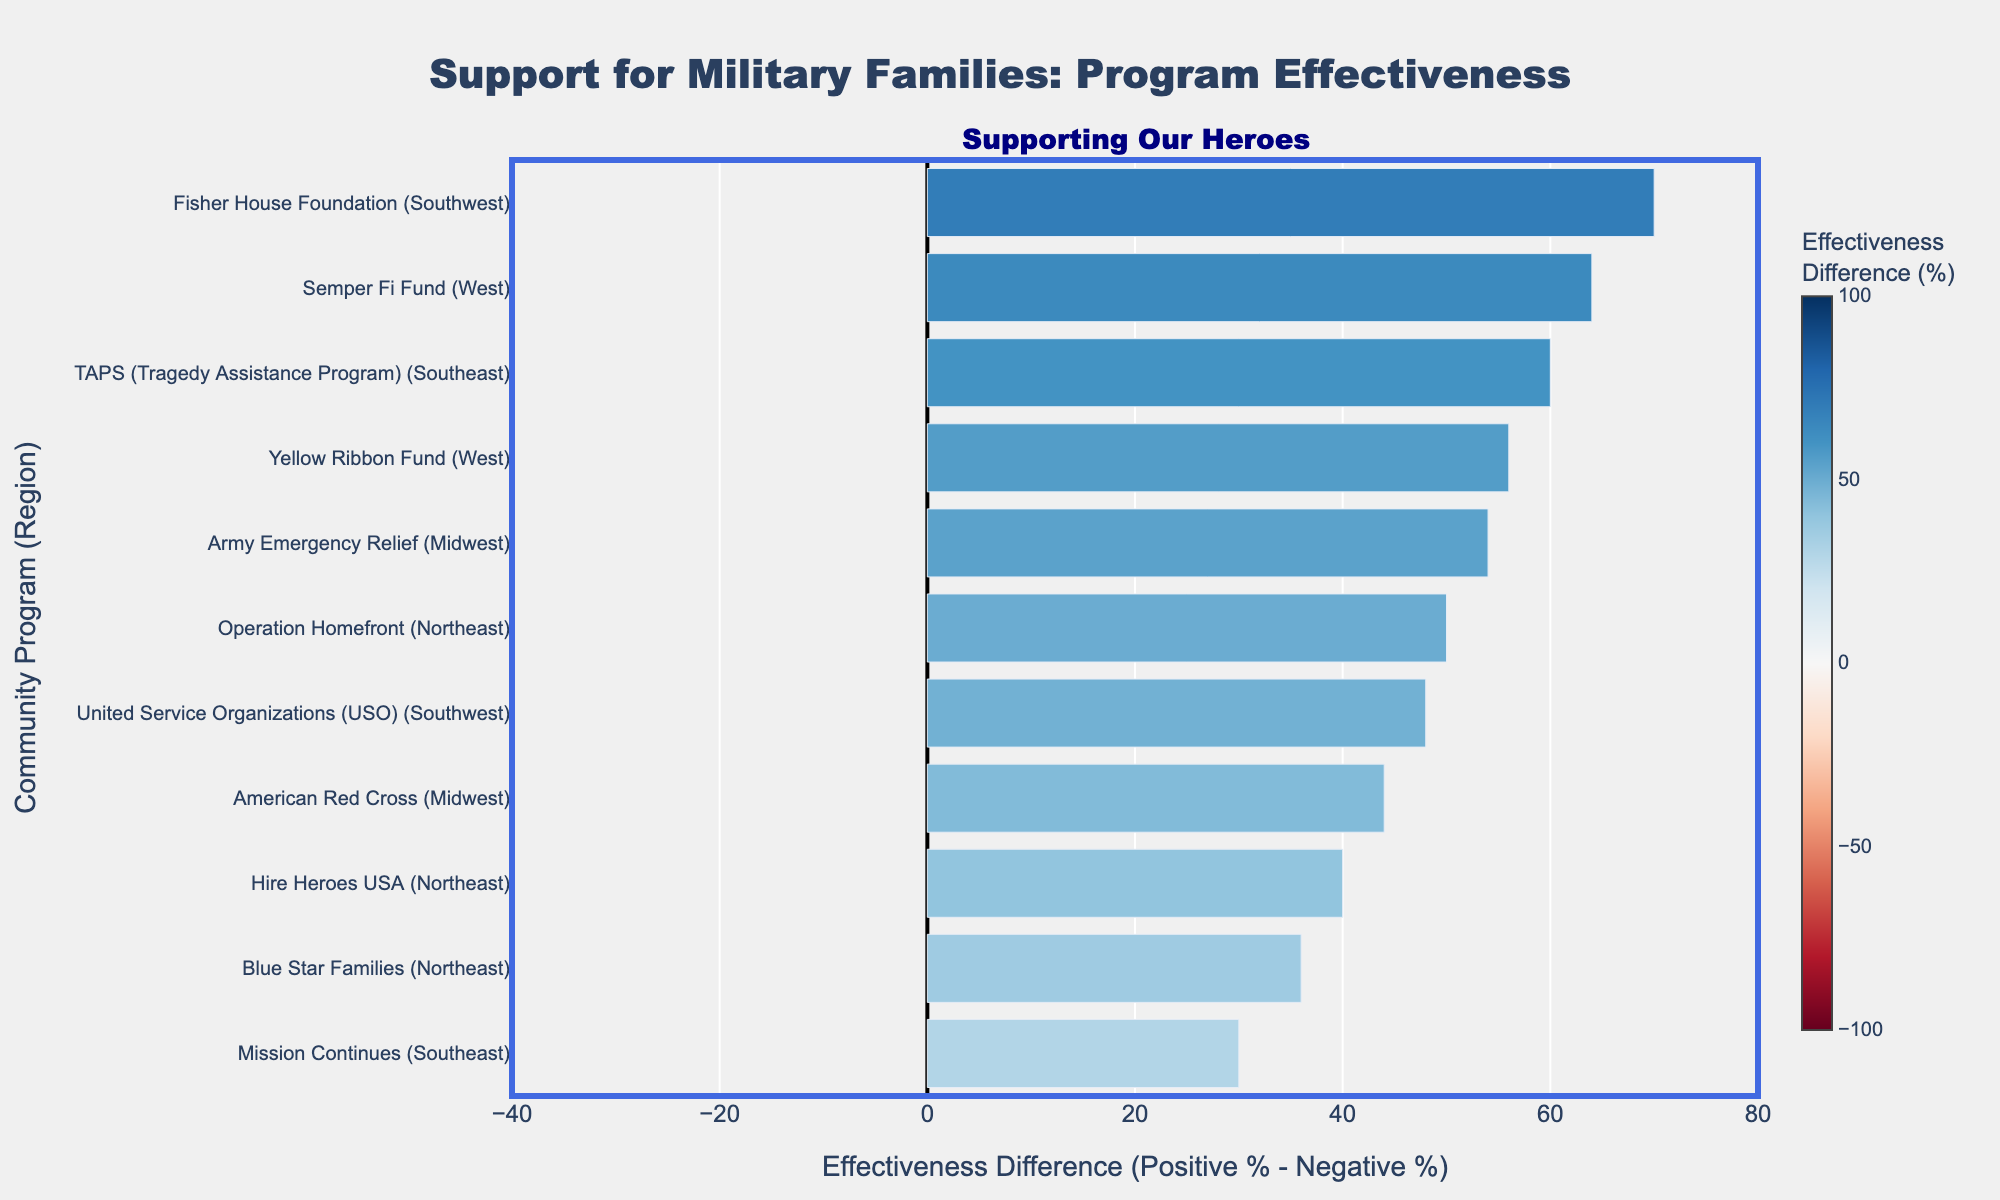What's the effectiveness difference for the 'Semper Fi Fund' program in the West region? The 'Semper Fi Fund' program falls in the West region and its effectiveness difference percentage can be observed directly from the bar's length and position. It's about +64%.
Answer: +64% Which region has the highest positive effectiveness for 'Grief Counseling'? By examining the programs providing 'Grief Counseling', we observe that 'TAPS (Tragedy Assistance Program)' in the Southeast region has the highest positive effectiveness listed at 80%.
Answer: Southeast How does 'American Red Cross' compare to 'United Service Organizations (USO)' in terms of effectiveness difference? The 'American Red Cross' has an effectiveness difference of +44%, while the 'USO' has an effectiveness difference of +48%. This implies USO has a slightly higher effectiveness difference.
Answer: USO What's the average effectiveness difference for programs in the Northeast region? The data for the Northeast includes 'Operation Homefront' (+50%), 'Blue Star Families' (+36%), and 'Hire Heroes USA' (+40%). The average is calculated as (50+36+40)/3 = 42%.
Answer: 42% Which community program in the Southwest has the highest effectiveness difference? The programs in the Southwest are 'Fisher House Foundation' with +70% and 'United Service Organizations (USO)' with +48%. The 'Fisher House Foundation' has the highest effectiveness difference among these.
Answer: Fisher House Foundation Which program in the Northeast has the lowest positive effectiveness? In the Northeast, the programs are 'Operation Homefront' with 75% positive effectiveness, 'Blue Star Families' with 68%, and 'Hire Heroes USA' with 70%. 'Blue Star Families' has the lowest positive effectiveness at 68%.
Answer: Blue Star Families Is the effectiveness difference for 'Mission Continues' program higher or lower than 'Army Emergency Relief'? The effectiveness difference for 'Mission Continues' is +30%, whereas for 'Army Emergency Relief' it is +54%. Therefore, 'Mission Continues' has a lower effectiveness difference.
Answer: Lower What's the sum of the effectiveness difference for all programs in the Midwest region? The programs in the Midwest are 'American Red Cross' with +44% and 'Army Emergency Relief' with +54%. The sum is 44+54 = 98%.
Answer: 98% Which program and in which region has the smallest effectiveness difference? By examining all the bars, 'Blue Star Families' in the Northeast has the smallest positive effectiveness difference, which is +36%.
Answer: Blue Star Families, Northeast 